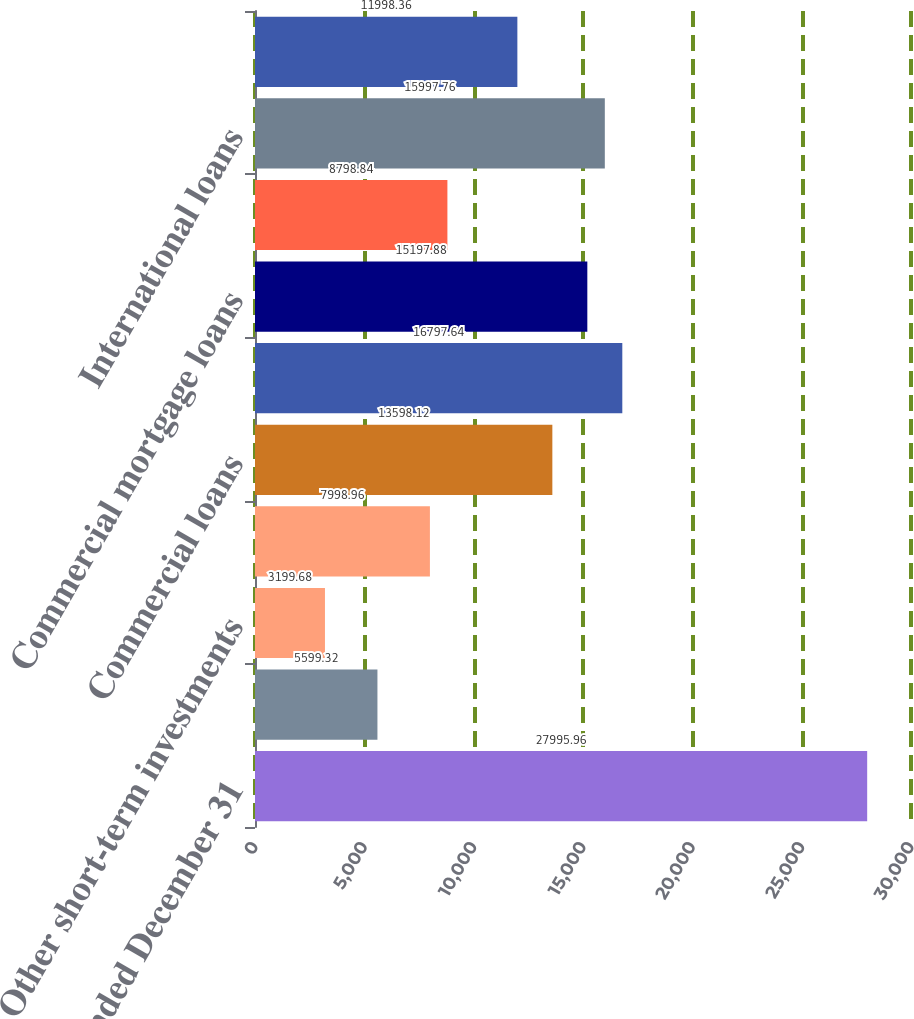Convert chart. <chart><loc_0><loc_0><loc_500><loc_500><bar_chart><fcel>Years Ended December 31<fcel>Interest-bearing deposits with<fcel>Other short-term investments<fcel>Investment securities<fcel>Commercial loans<fcel>Real estate construction loans<fcel>Commercial mortgage loans<fcel>Lease financing<fcel>International loans<fcel>Residential mortgage loans<nl><fcel>27996<fcel>5599.32<fcel>3199.68<fcel>7998.96<fcel>13598.1<fcel>16797.6<fcel>15197.9<fcel>8798.84<fcel>15997.8<fcel>11998.4<nl></chart> 